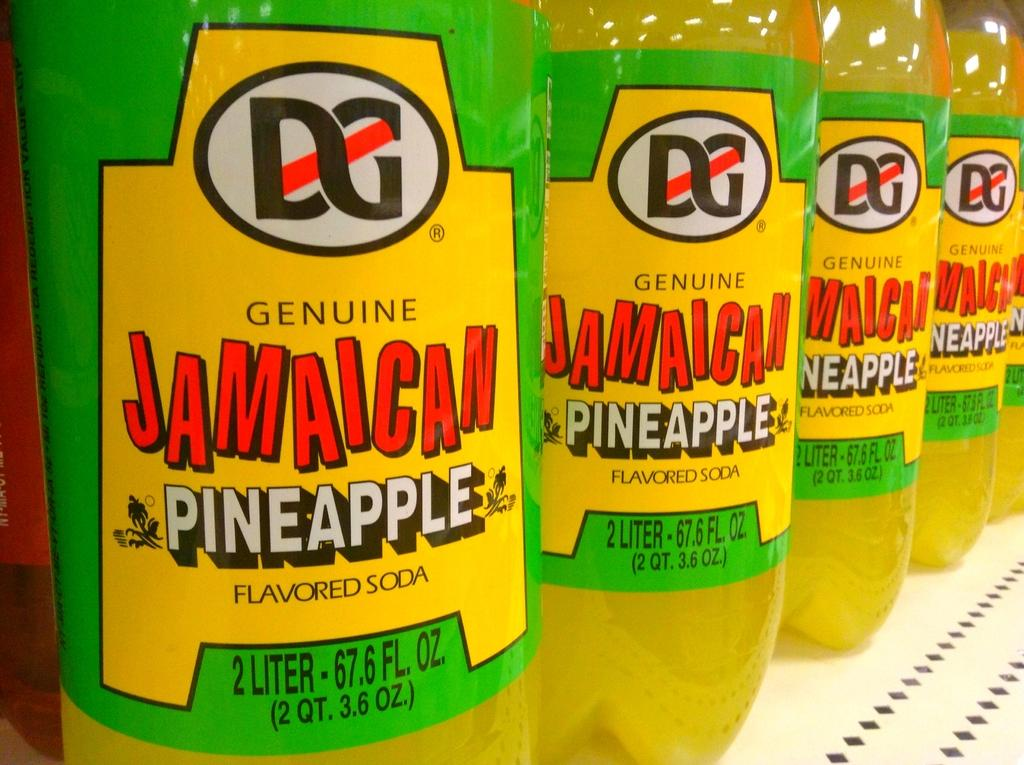What type of soda is featured in the image? There are pineapple flavored soda bottles in the image. How are the soda bottles arranged in the image? The soda bottles are arranged on a shelf. What type of fruit is growing on the cows in the image? There are no cows present in the image, and therefore no fruit growing on them. 